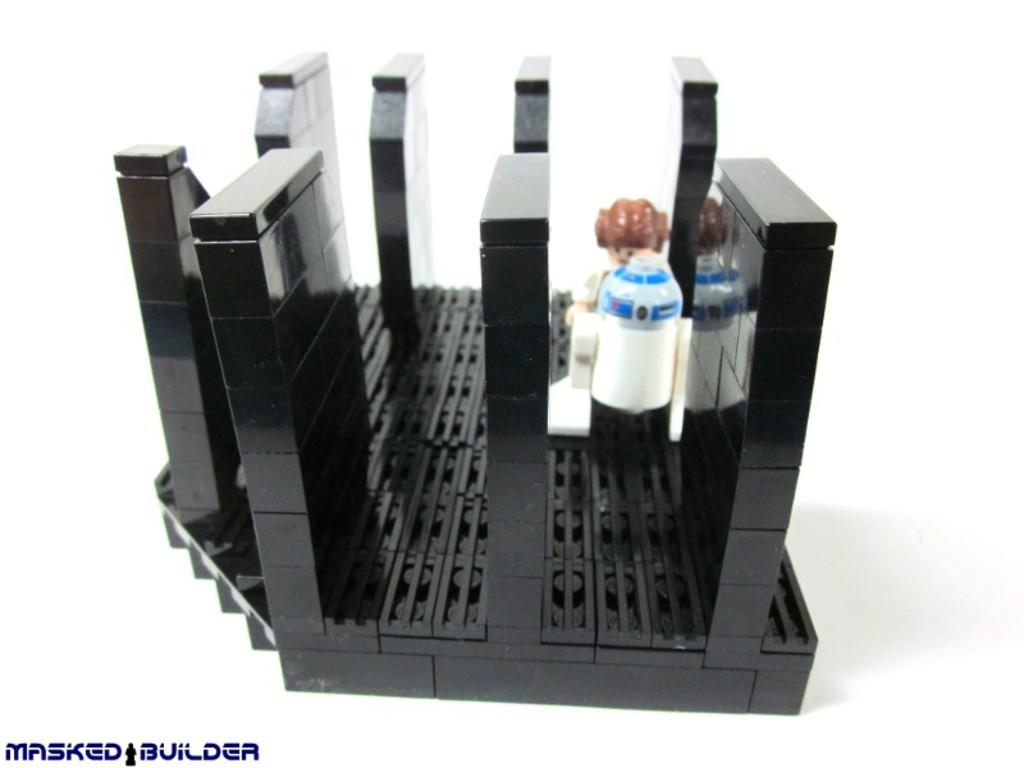<image>
Provide a brief description of the given image. A star wars themed toy with a Masked Builder logo at the bottom left. 